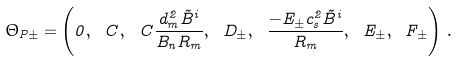<formula> <loc_0><loc_0><loc_500><loc_500>\Theta _ { P \pm } = \left ( 0 , \ C , \ C \frac { d _ { m } ^ { 2 } \tilde { B } ^ { i } } { B _ { n } R _ { m } } , \ D _ { \pm } , \ \frac { - E _ { \pm } c _ { s } ^ { 2 } \tilde { B } ^ { i } } { R _ { m } } , \ E _ { \pm } , \ F _ { \pm } \right ) \, .</formula> 